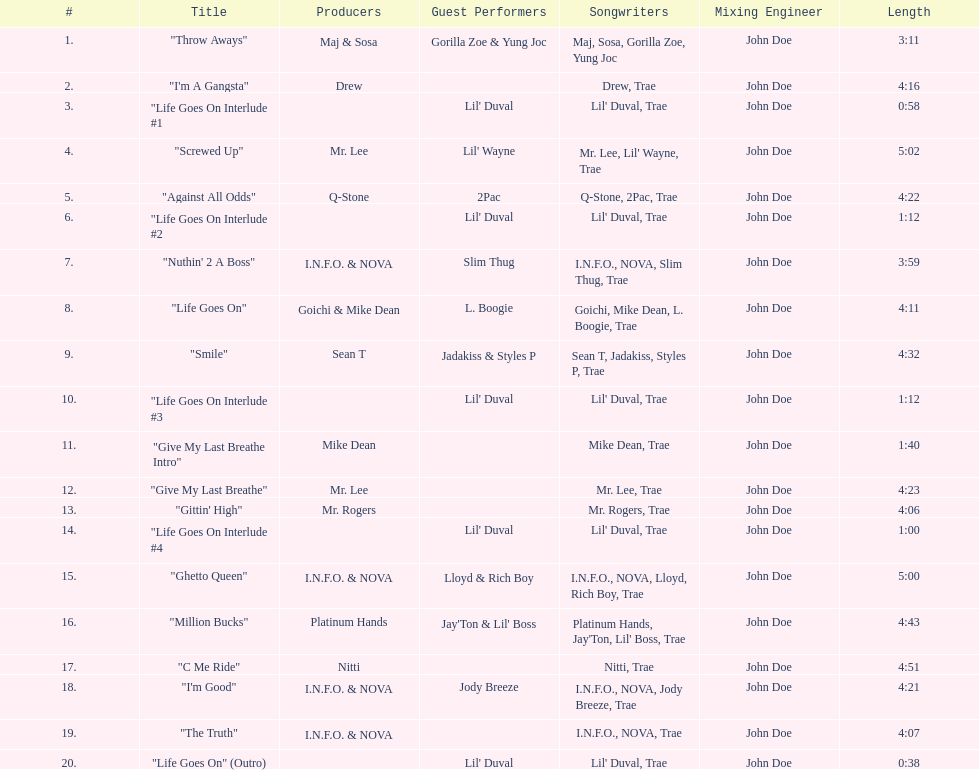Which tracks feature the same producer(s) in consecutive order on this album? "I'm Good", "The Truth". 